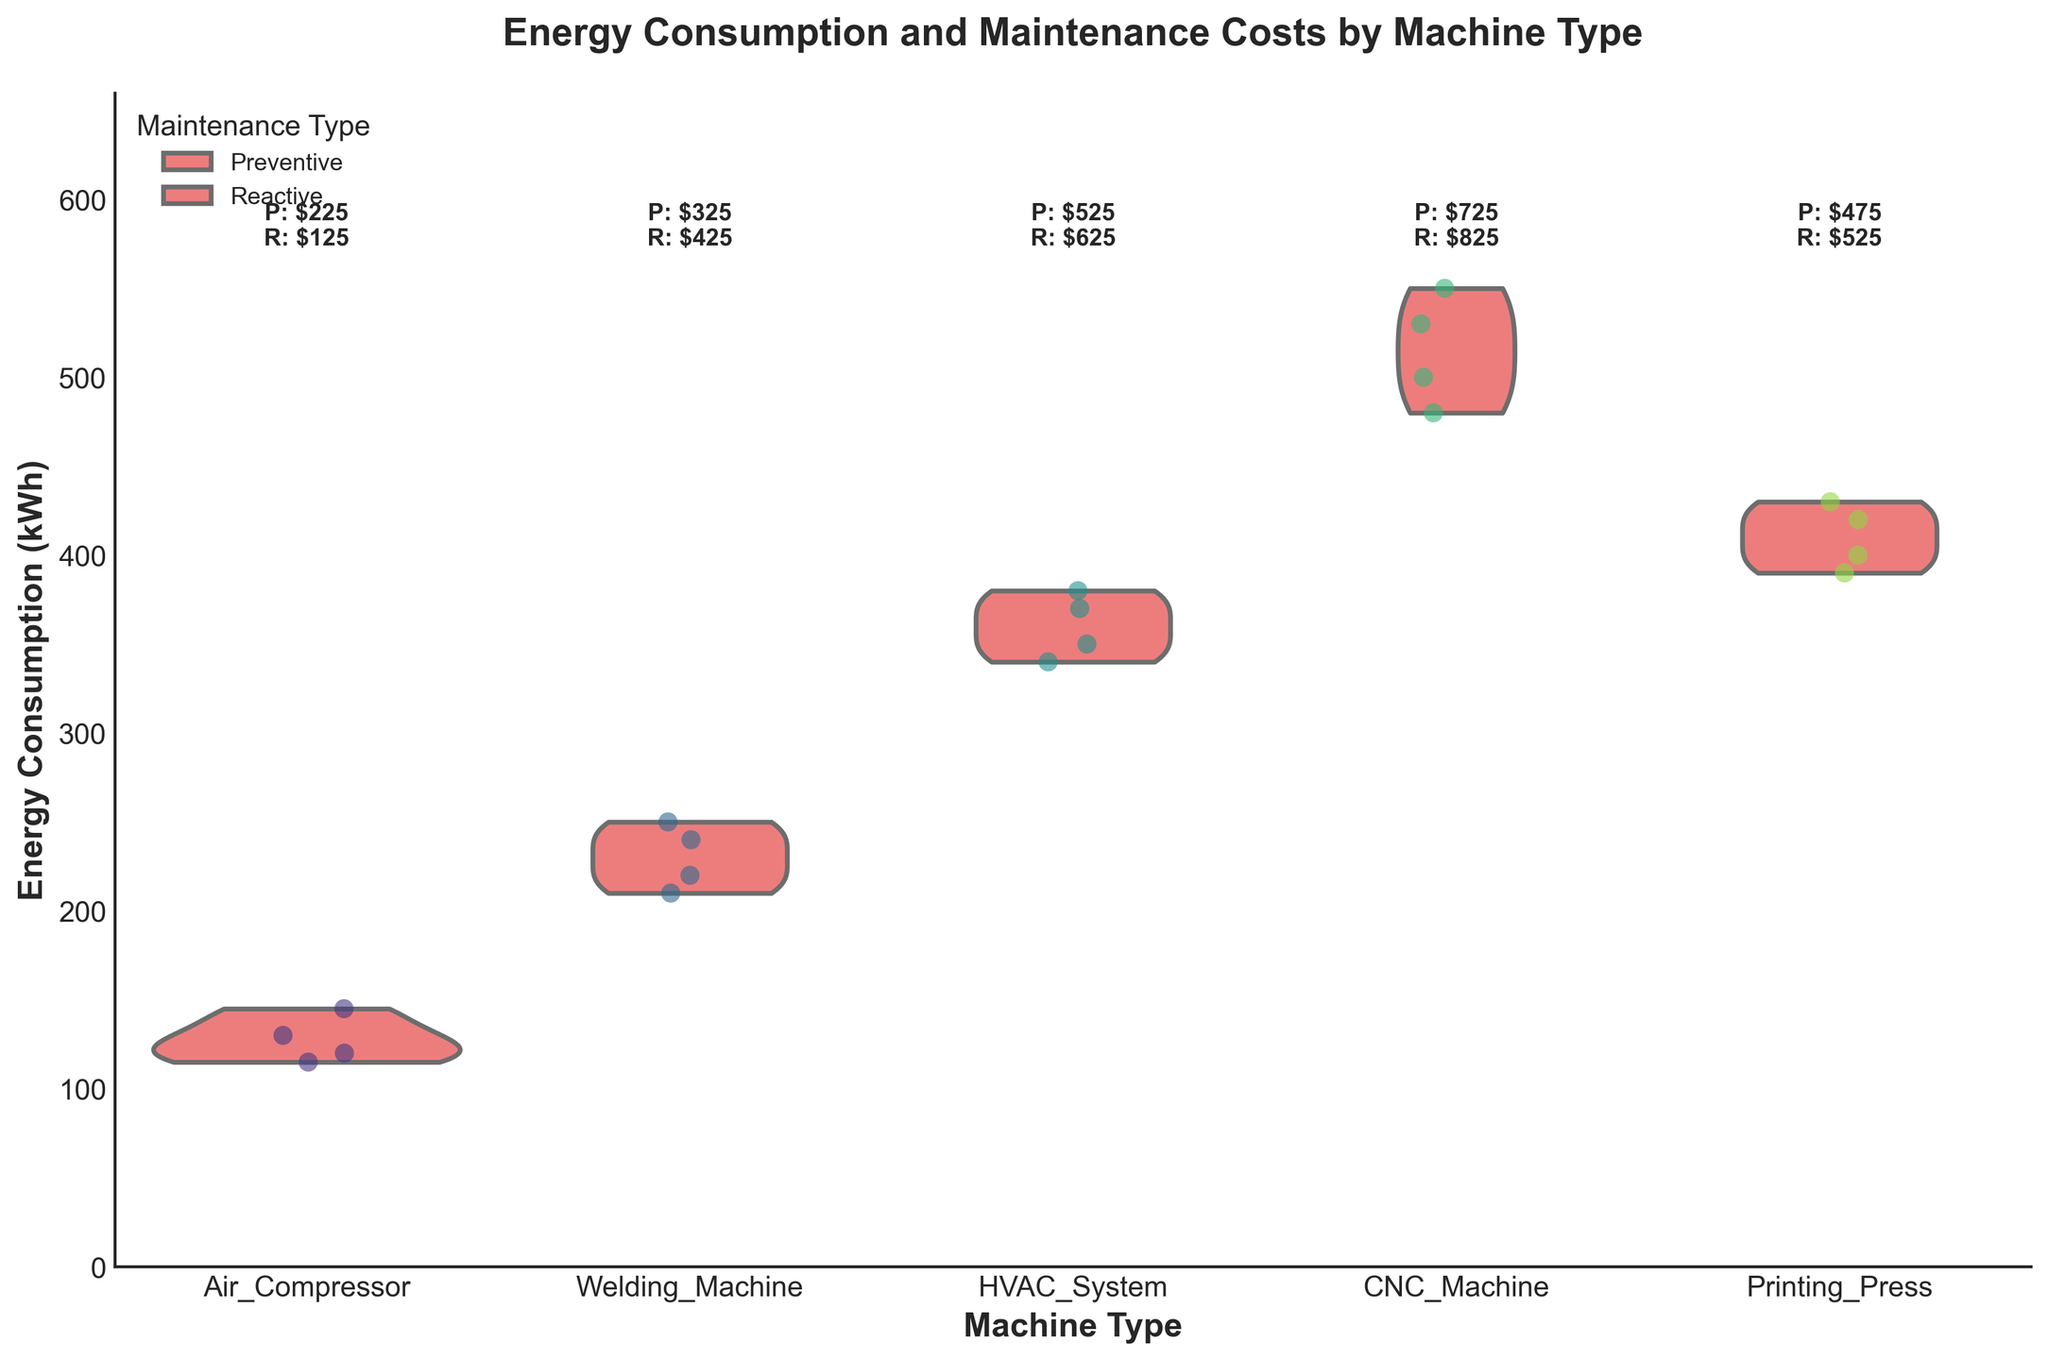What is the title of the figure? The title is typically displayed at the top of the figure and summarizes what the chart is about. In this case, it is clearly stated.
Answer: Energy Consumption and Maintenance Costs by Machine Type Which machine has the highest maximum energy consumption? To determine this, look at the upward extension of the violin plots. The machine with the highest peak in the plot indicates the highest maximum energy consumption.
Answer: CNC Machine How does the average maintenance cost for preventive and reactive maintenance compare for the Welding Machine? The figure includes mean maintenance costs listed above the violin plots. Check the corresponding text for the Welding Machine's preventive and reactive costs.
Answer: Preventive: $325, Reactive: $425 Which machine shows the most spread (variability) in energy consumption? Variability can be observed by the width of the violin plot. The wider the violin plot, the more variability in energy consumption it indicates.
Answer: CNC Machine What is the range of energy consumption for the HVAC System machine? The range can be observed by identifying the minimum and maximum points of the jittered dots for the HVAC System.
Answer: 340 - 380 kWh Which machine generally consumes less energy: the Printing Press or the Air Compressor? Compare the overall spread and central tendency of the violin plots for both machines. Identify which has a lower energy consumption distribution.
Answer: Air Compressor For which type of maintenance (preventive or reactive) is the cost generally higher for the HVAC System? Look at the text above the violin plot for the HVAC System to compare the average maintenance costs.
Answer: Reactive How does the energy consumption variability of the Air Compressor compare to the Welding Machine? Compare the width of the violin plots for both machines. The plot with lesser width indicates lower variability.
Answer: Air Compressor has less variability What is the typical energy consumption range for the Welding Machine based on the violin plot? Identify the central bulk of the violin plot, which indicates where most data points lie. Usually, the thicker middle part of the plot.
Answer: 210 - 240 kWh Which machine has the closest average preventive and reactive maintenance costs? Compare the texts indicating preventive and reactive costs for each machine type, and find the smallest difference between these values.
Answer: Printing Press 